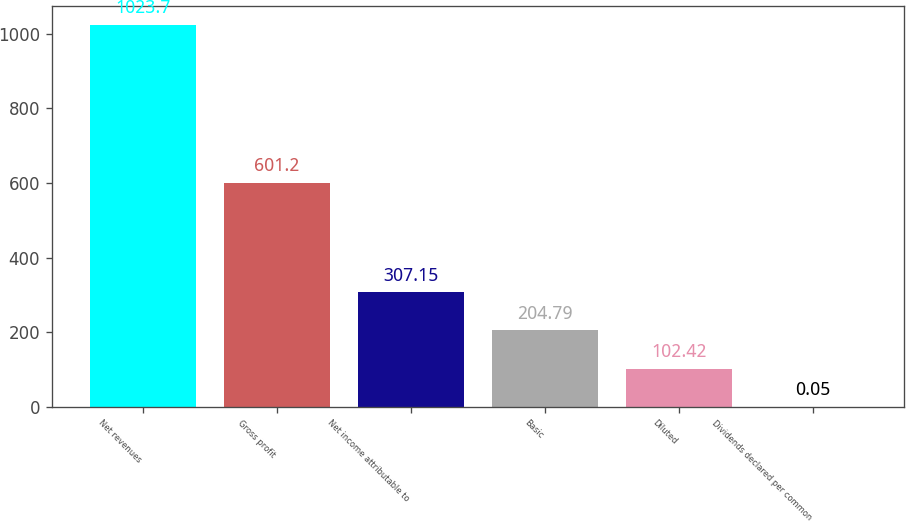<chart> <loc_0><loc_0><loc_500><loc_500><bar_chart><fcel>Net revenues<fcel>Gross profit<fcel>Net income attributable to<fcel>Basic<fcel>Diluted<fcel>Dividends declared per common<nl><fcel>1023.7<fcel>601.2<fcel>307.15<fcel>204.79<fcel>102.42<fcel>0.05<nl></chart> 